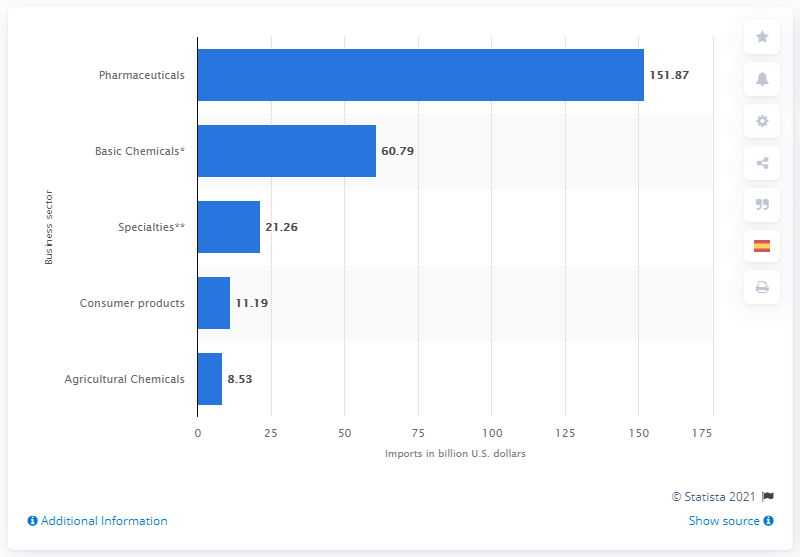Identify some key points in this picture. In 2019, the value of imports from the pharmaceuticals sector was $151.87 million. 